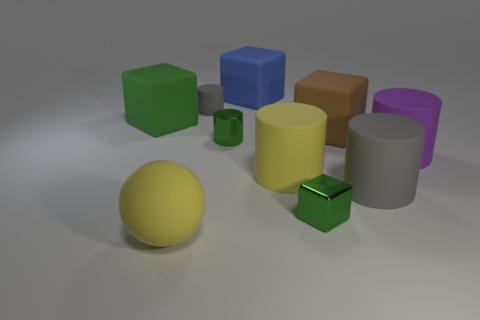What number of yellow cylinders are there?
Offer a terse response. 1. What is the material of the purple object on the right side of the tiny green thing in front of the metal thing behind the small green cube?
Your answer should be very brief. Rubber. How many tiny objects are to the right of the small metal thing left of the blue block?
Your answer should be compact. 1. The small metal object that is the same shape as the large green thing is what color?
Make the answer very short. Green. Is the material of the big green object the same as the small gray thing?
Your response must be concise. Yes. What number of balls are big brown things or green objects?
Provide a succinct answer. 0. What size is the green cube to the right of the large yellow rubber object in front of the gray object that is to the right of the tiny green metal block?
Your response must be concise. Small. There is a purple rubber thing that is the same shape as the tiny gray matte thing; what size is it?
Provide a succinct answer. Large. There is a large brown rubber block; how many tiny metal cubes are to the right of it?
Your answer should be very brief. 0. There is a matte cylinder behind the brown cube; is it the same color as the shiny cube?
Make the answer very short. No. 